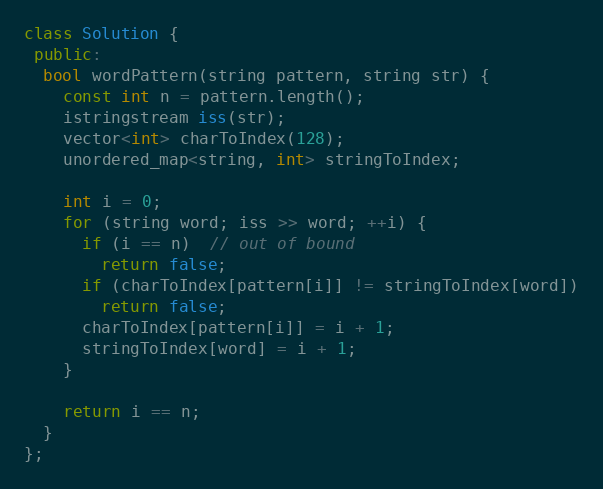Convert code to text. <code><loc_0><loc_0><loc_500><loc_500><_C++_>class Solution {
 public:
  bool wordPattern(string pattern, string str) {
    const int n = pattern.length();
    istringstream iss(str);
    vector<int> charToIndex(128);
    unordered_map<string, int> stringToIndex;

    int i = 0;
    for (string word; iss >> word; ++i) {
      if (i == n)  // out of bound
        return false;
      if (charToIndex[pattern[i]] != stringToIndex[word])
        return false;
      charToIndex[pattern[i]] = i + 1;
      stringToIndex[word] = i + 1;
    }

    return i == n;
  }
};
</code> 